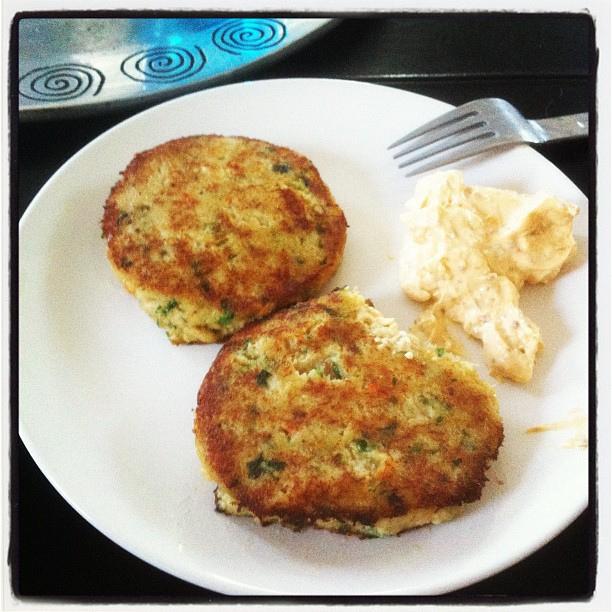Has someone taken a bite?
Write a very short answer. Yes. What is the design on the platter to the rear?
Keep it brief. Spirals. What utensil is the meal being eaten with?
Answer briefly. Fork. What kind of food is pictured?
Answer briefly. Latkes. 